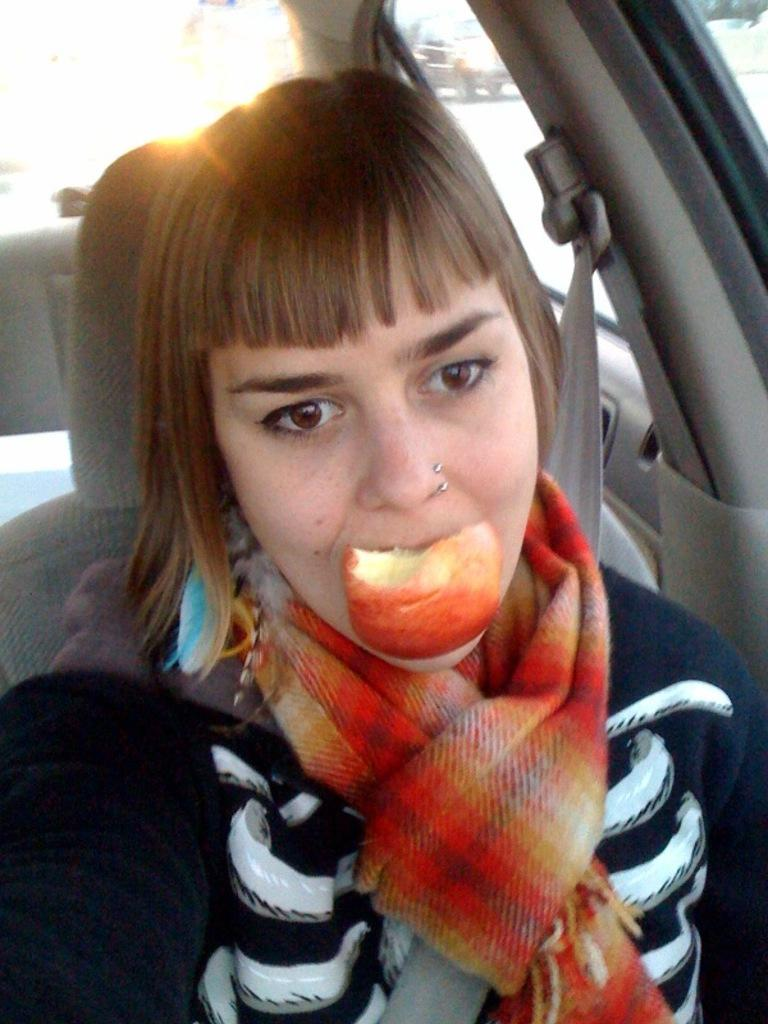Who is the main subject in the image? There is a woman in the image. What is the woman doing in the image? The woman is eating an apple. What else can be seen in the image besides the woman? There is a car in the image. What type of chicken is the woman holding in the image? There is no chicken present in the image; the woman is eating an apple. 